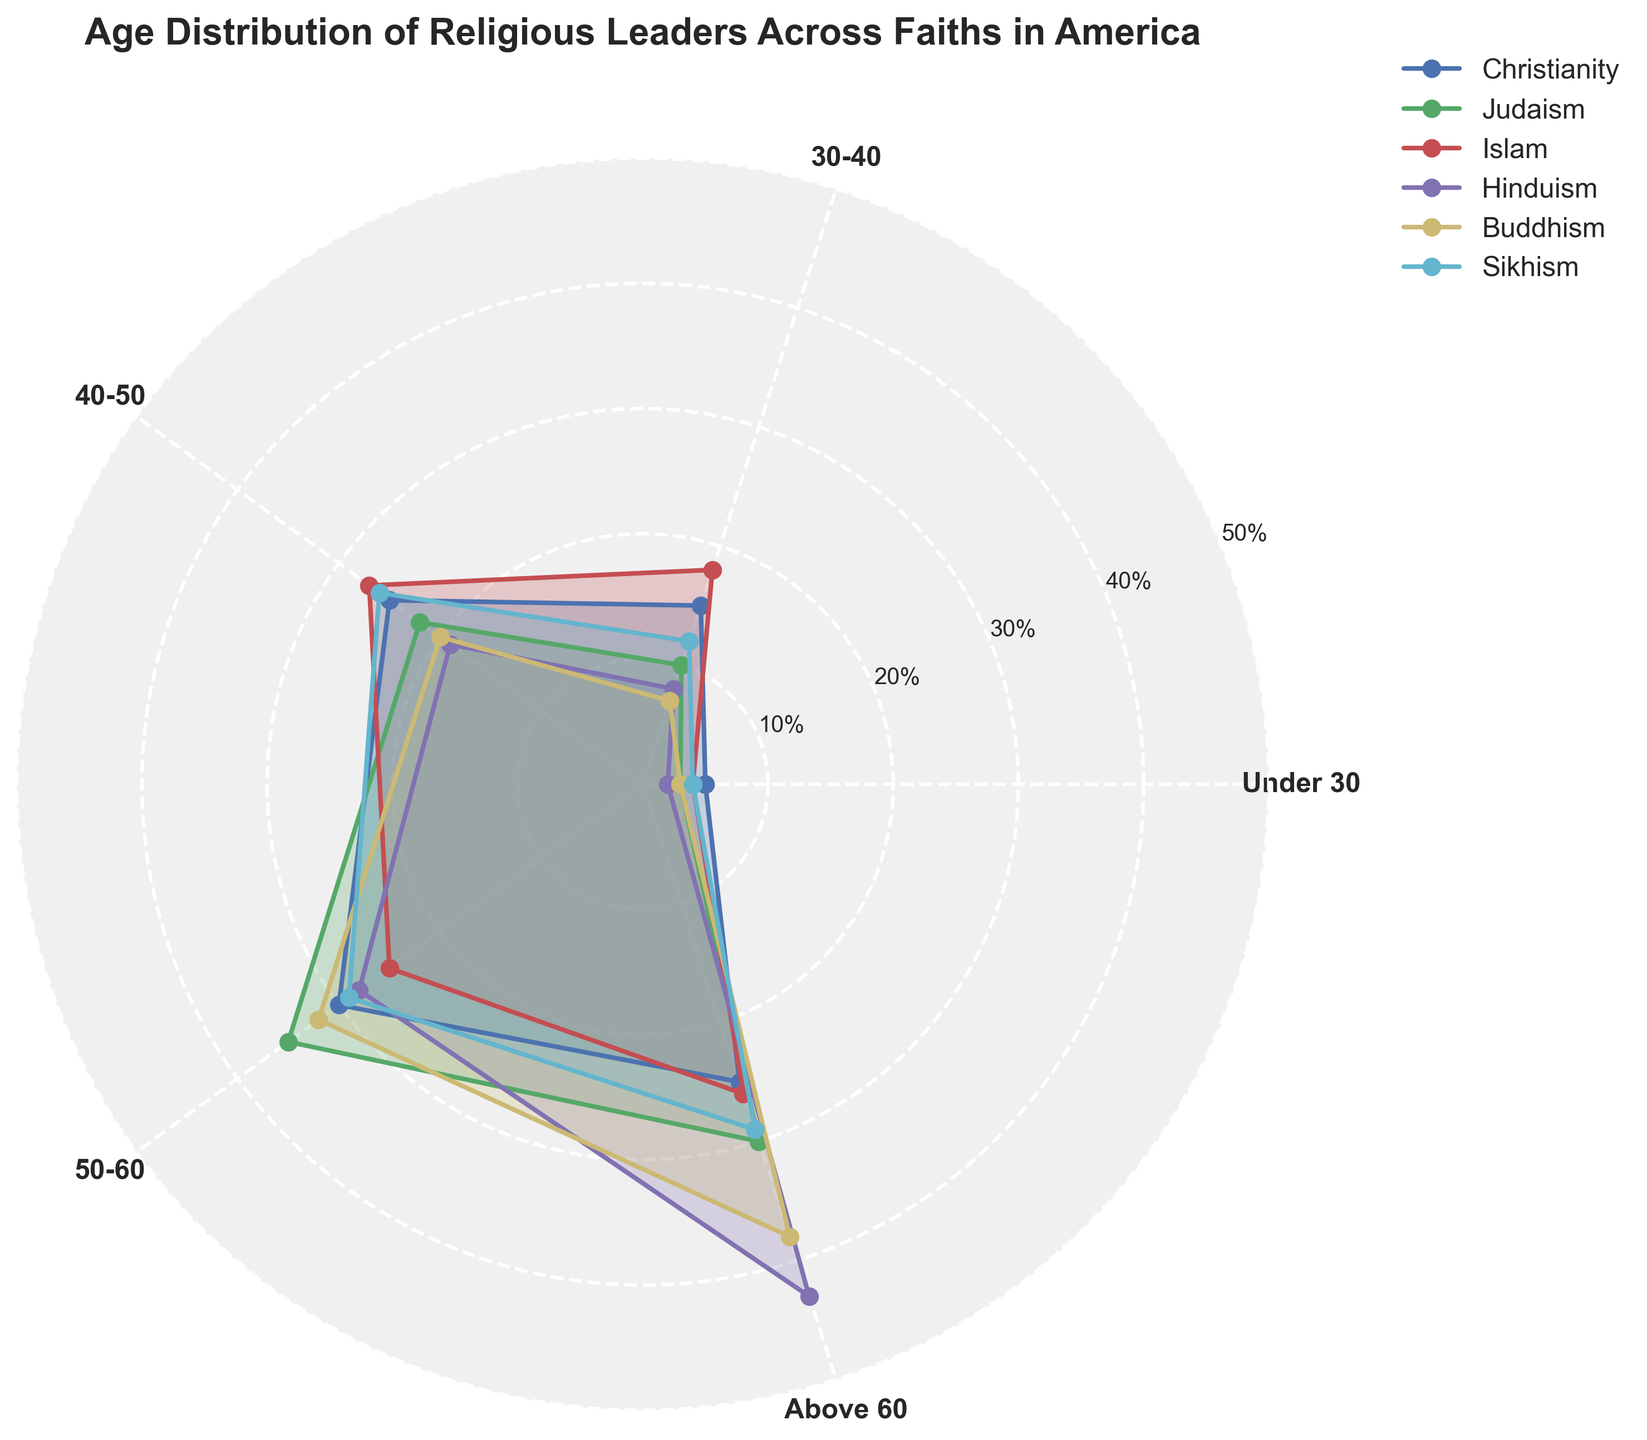what is the title of the plot? The title of the plot is usually placed at the top center of the figure and provides a summary of the content. Here, the title is written in a bold format.
Answer: Age Distribution of Religious Leaders Across Faiths in America Which faith has the highest percentage of leaders above 60? By comparing the 'Above 60' section of the polar chart for all faiths, we identify the highest value. The largest area in this section belongs to Hinduism.
Answer: Hinduism How many faiths are represented in the plot? The plot shows separate lines and labels for each faith, indicating how many faiths are included. Counting the distinct labels (Christianity, Judaism, Islam, Hinduism, Buddhism, Sikhism), we find that there are 6 faiths represented.
Answer: 6 What's the percentage difference in leaders aged 50-60 between Buddhism and Christianity? Look at the '50-60' section for Buddhism and Christianity. Subtract the percentage of Christianity (30%) from that of Buddhism (32%).
Answer: 2% Which age group has the least percentage of Hindu leaders? Examine each age group's section for Hinduism and identify the smallest value. The 'Under 30' group, with only 2%, is the smallest.
Answer: Under 30 Is the age distribution for Sikhism more balanced compared to other faiths? To determine balance, check if the values for each age group in Sikhism are close to each other. Sikhism has values like 4%, 12%, 26%, 29%, 29%, which are not extremely varied. Other faiths show a larger variance.
Answer: Yes Which faith has the most diverse age distribution among its leaders? Review the range of percentage values in the age groups for each faith. Hinduism has a wide range, from 2% (Under 30) to 43% (Above 60), indicating high diversity.
Answer: Hinduism In which age group do Christian and Jewish leaders show the highest percentage difference? Compare the percentages in each age group for both Christianity and Judaism, and find where the difference is greatest. For the '50-60' group, Christianity has 30% while Judaism has 35%, a 5% difference.
Answer: 50-60 How does the percentage of leaders in the 30-40 age group for Islam compare to the same age group in Sikhism? By comparing the '30-40' section for Islam (18%) and Sikhism (12%) on the polar chart, we see that Islam has a higher percentage.
Answer: Islam has a higher percentage Which faith shows the highest percentage of leaders in the 40-50 age group? Identify the faith with the highest value in the '40-50' section of the polar chart. This section peaks for Islam with 27%.
Answer: Islam 